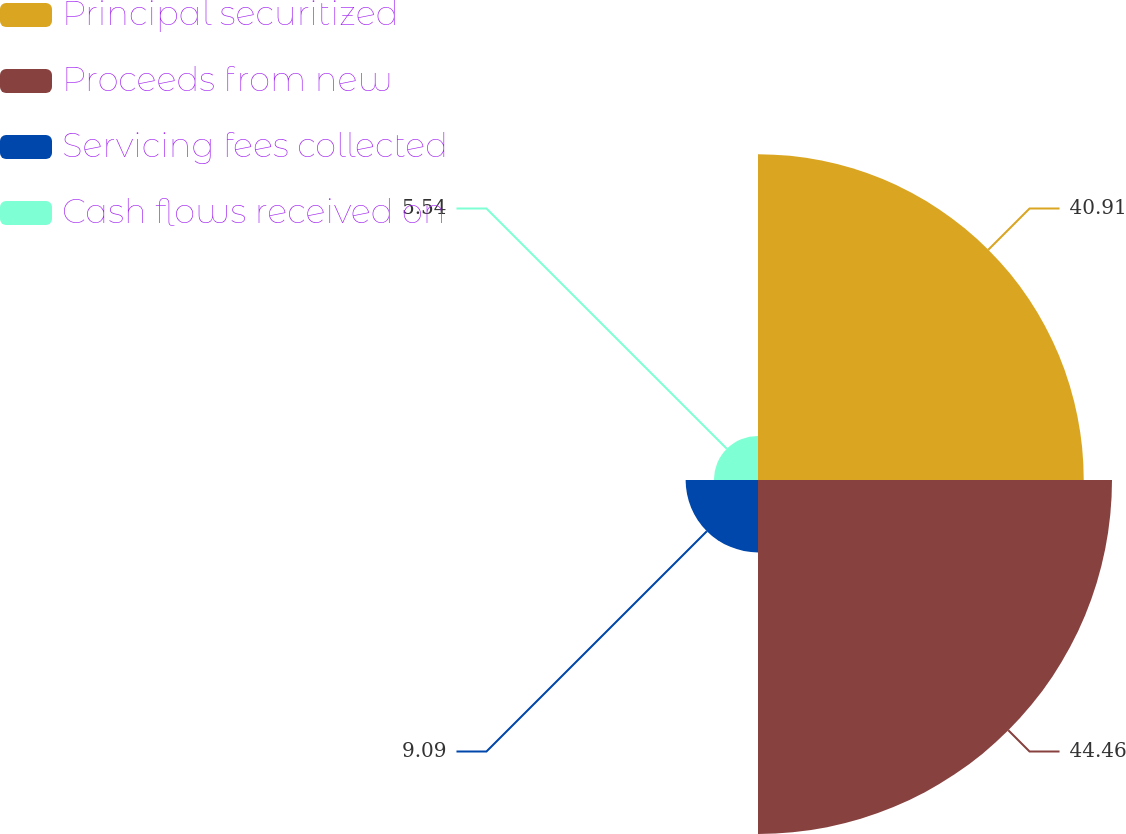Convert chart. <chart><loc_0><loc_0><loc_500><loc_500><pie_chart><fcel>Principal securitized<fcel>Proceeds from new<fcel>Servicing fees collected<fcel>Cash flows received on<nl><fcel>40.91%<fcel>44.46%<fcel>9.09%<fcel>5.54%<nl></chart> 